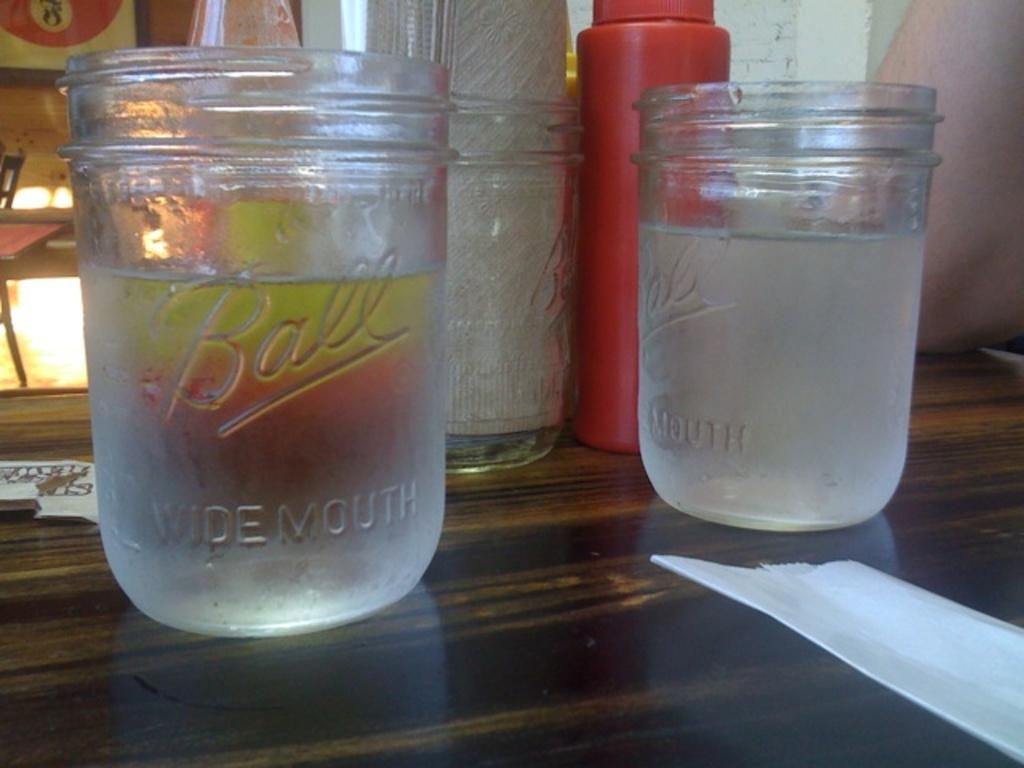<image>
Relay a brief, clear account of the picture shown. A half full jar with the word Ball on it 